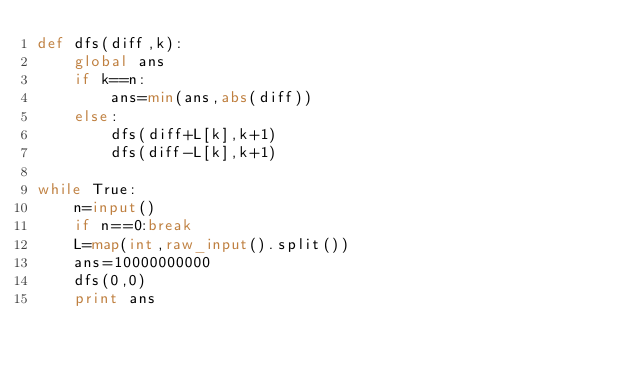Convert code to text. <code><loc_0><loc_0><loc_500><loc_500><_Python_>def dfs(diff,k):
    global ans
    if k==n:
        ans=min(ans,abs(diff))
    else:
        dfs(diff+L[k],k+1)
        dfs(diff-L[k],k+1)

while True:
    n=input()
    if n==0:break
    L=map(int,raw_input().split())
    ans=10000000000
    dfs(0,0)
    print ans</code> 